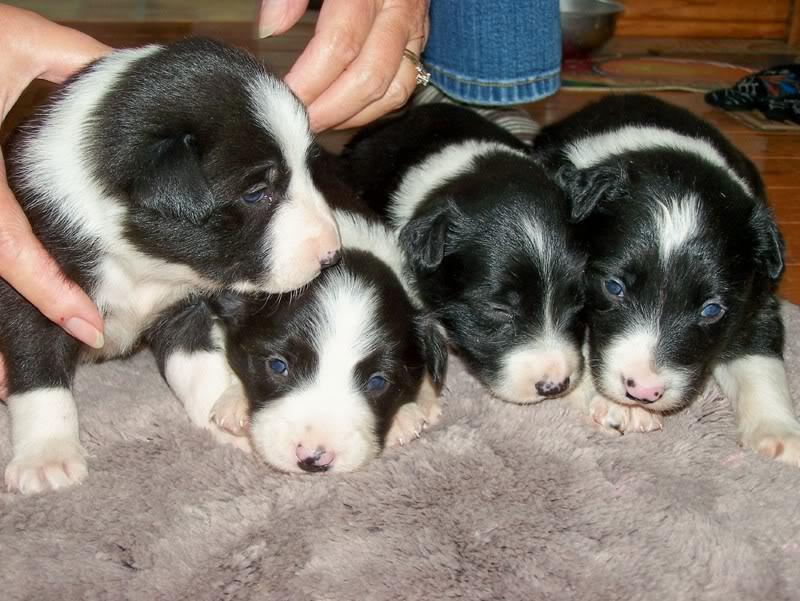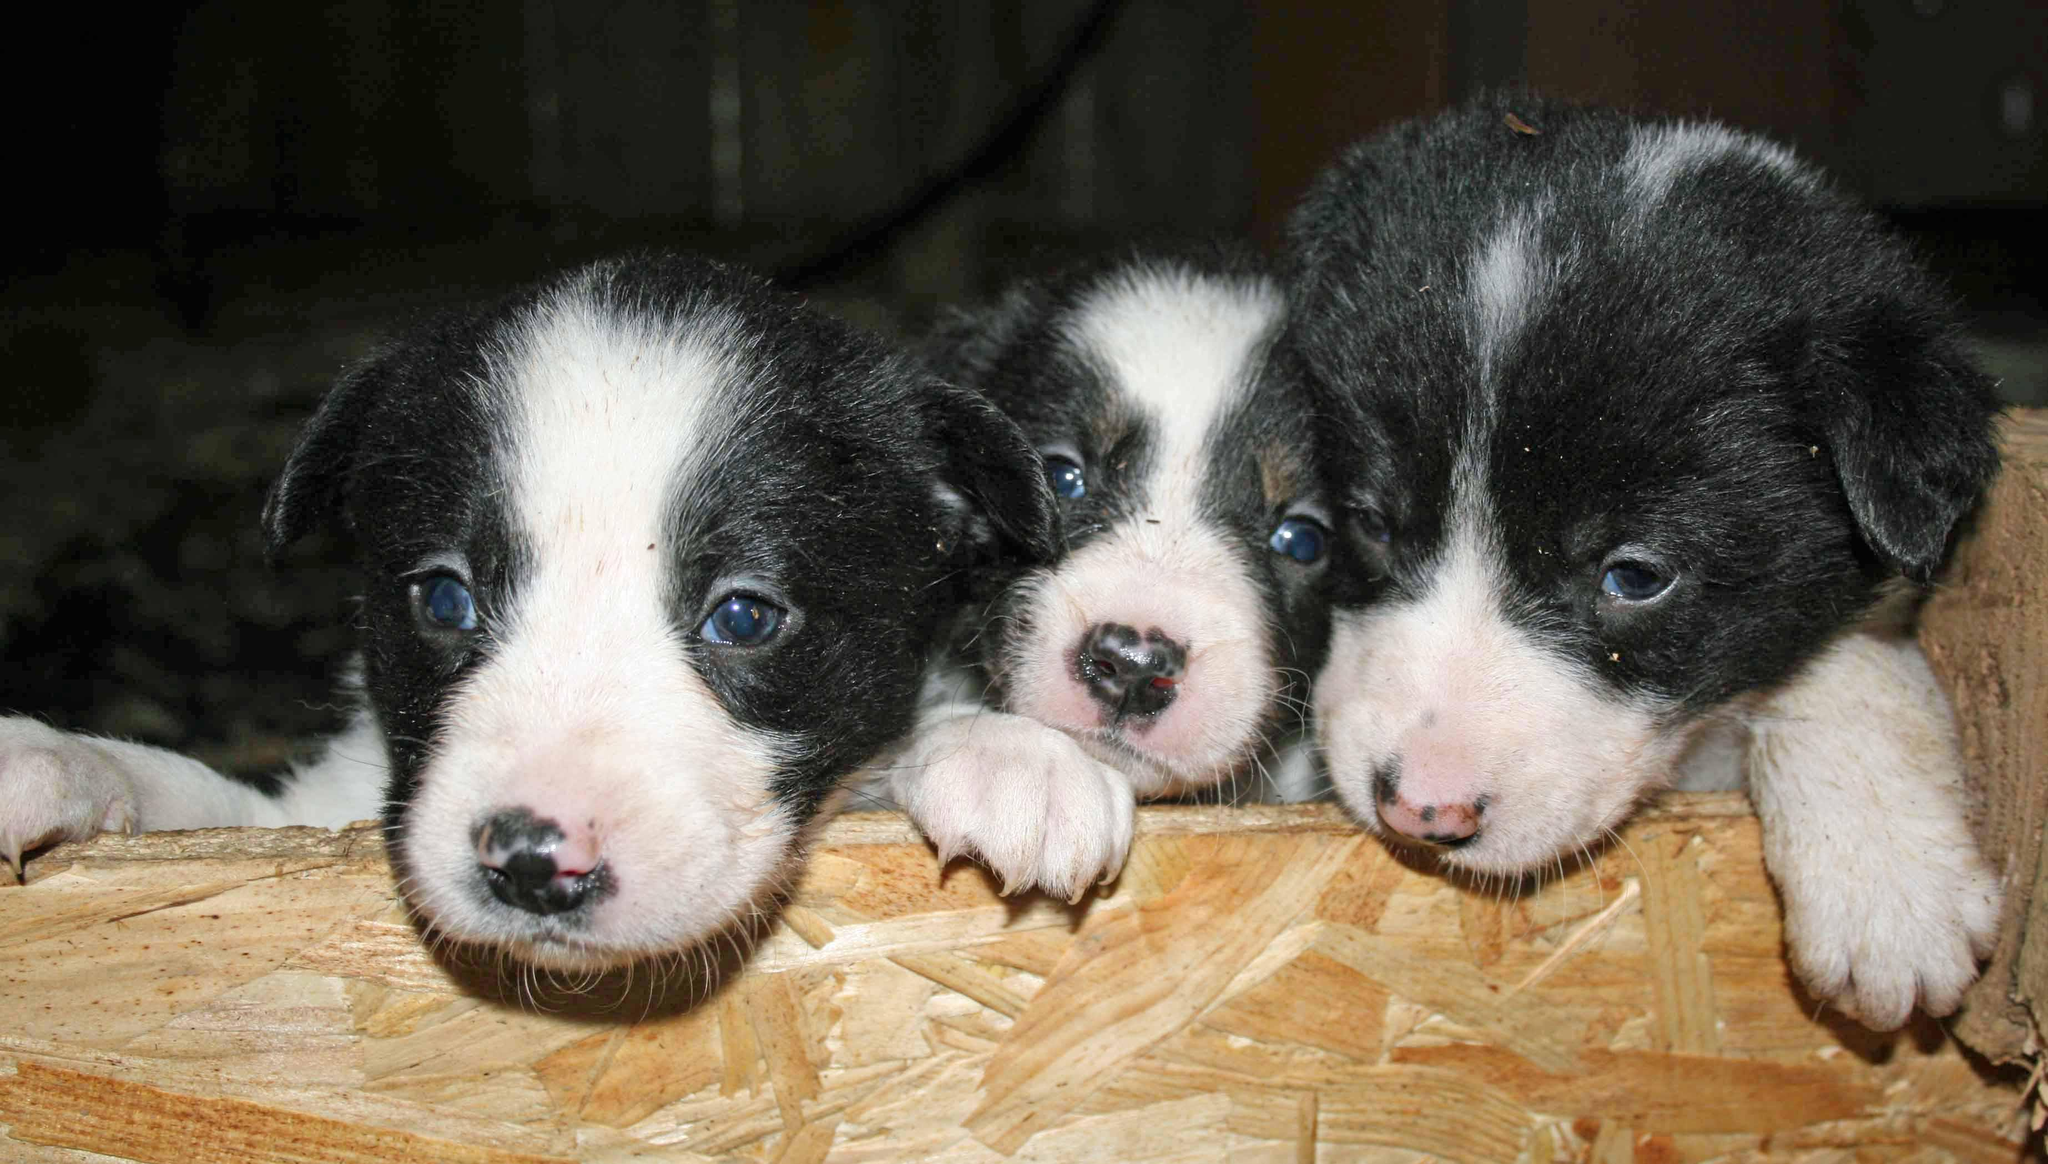The first image is the image on the left, the second image is the image on the right. Analyze the images presented: Is the assertion "There is at least one human petting puppies in one of the images." valid? Answer yes or no. Yes. The first image is the image on the left, the second image is the image on the right. Assess this claim about the two images: "An image contains exactly four puppies, all black and white and most of them reclining in a row.". Correct or not? Answer yes or no. Yes. 